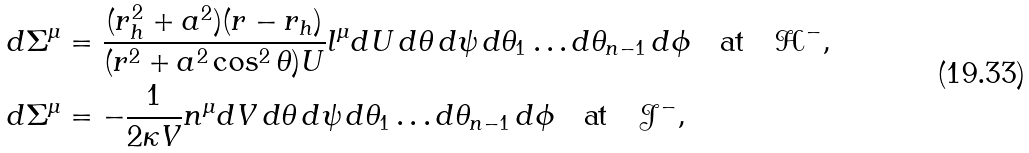Convert formula to latex. <formula><loc_0><loc_0><loc_500><loc_500>d \Sigma ^ { \mu } & = \frac { ( r _ { h } ^ { 2 } + a ^ { 2 } ) ( r - r _ { h } ) } { ( r ^ { 2 } + a ^ { 2 } \cos ^ { 2 } \theta ) U } l ^ { \mu } d U \, d \theta \, d \psi \, d \theta _ { 1 } \dots d \theta _ { n - 1 } \, d \phi \quad \text {at} \quad \mathcal { H } ^ { - } , \\ d \Sigma ^ { \mu } & = - \frac { 1 } { 2 \kappa V } n ^ { \mu } d V \, d \theta \, d \psi \, d \theta _ { 1 } \dots d \theta _ { n - 1 } \, d \phi \quad \text {at} \quad \mathcal { J } ^ { - } ,</formula> 